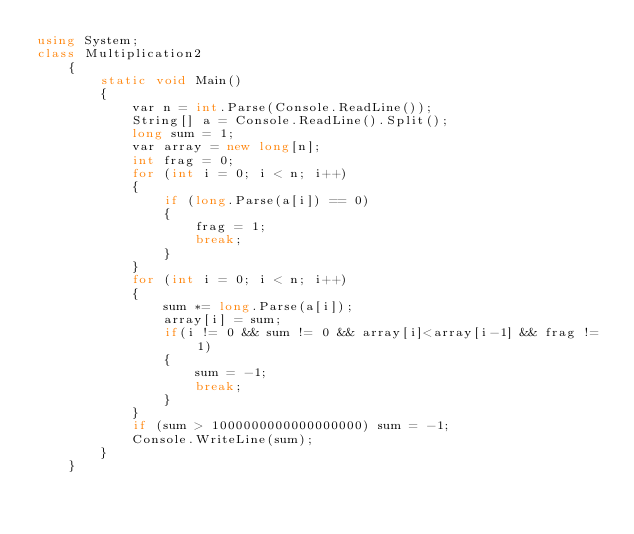<code> <loc_0><loc_0><loc_500><loc_500><_C#_>using System;
class Multiplication2
    {
        static void Main()
        {
            var n = int.Parse(Console.ReadLine());
            String[] a = Console.ReadLine().Split();
            long sum = 1;
            var array = new long[n];
            int frag = 0;
            for (int i = 0; i < n; i++)
            {
                if (long.Parse(a[i]) == 0)
                {
                    frag = 1;
                    break;
                }
            }
            for (int i = 0; i < n; i++)
            {
                sum *= long.Parse(a[i]);
                array[i] = sum;
                if(i != 0 && sum != 0 && array[i]<array[i-1] && frag != 1)
                {
                    sum = -1;
                    break;
                }
            }
            if (sum > 1000000000000000000) sum = -1;
            Console.WriteLine(sum);
        }
    }</code> 